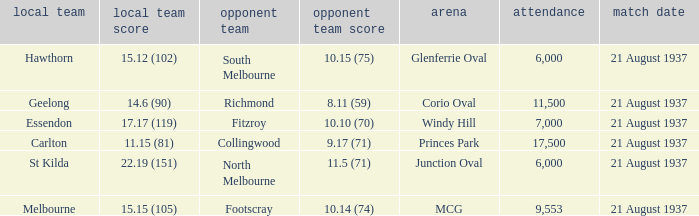Where did Richmond play? Corio Oval. Can you give me this table as a dict? {'header': ['local team', 'local team score', 'opponent team', 'opponent team score', 'arena', 'attendance', 'match date'], 'rows': [['Hawthorn', '15.12 (102)', 'South Melbourne', '10.15 (75)', 'Glenferrie Oval', '6,000', '21 August 1937'], ['Geelong', '14.6 (90)', 'Richmond', '8.11 (59)', 'Corio Oval', '11,500', '21 August 1937'], ['Essendon', '17.17 (119)', 'Fitzroy', '10.10 (70)', 'Windy Hill', '7,000', '21 August 1937'], ['Carlton', '11.15 (81)', 'Collingwood', '9.17 (71)', 'Princes Park', '17,500', '21 August 1937'], ['St Kilda', '22.19 (151)', 'North Melbourne', '11.5 (71)', 'Junction Oval', '6,000', '21 August 1937'], ['Melbourne', '15.15 (105)', 'Footscray', '10.14 (74)', 'MCG', '9,553', '21 August 1937']]} 